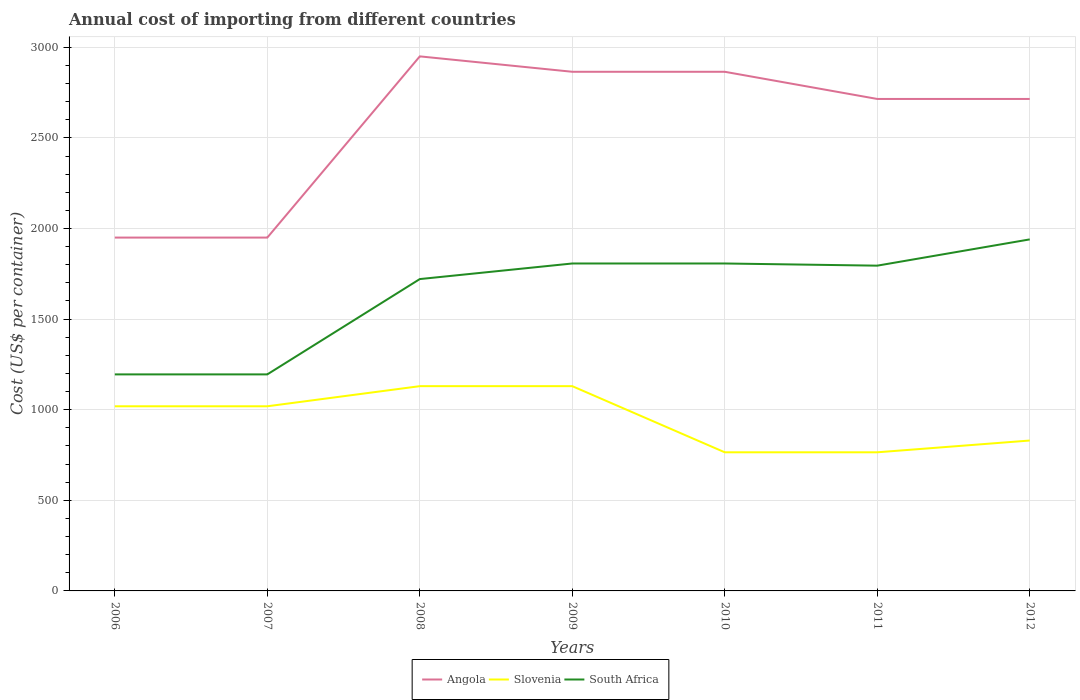How many different coloured lines are there?
Offer a very short reply. 3. Does the line corresponding to South Africa intersect with the line corresponding to Slovenia?
Your answer should be very brief. No. Is the number of lines equal to the number of legend labels?
Make the answer very short. Yes. Across all years, what is the maximum total annual cost of importing in Slovenia?
Give a very brief answer. 765. What is the total total annual cost of importing in Slovenia in the graph?
Your answer should be very brief. 189. What is the difference between the highest and the second highest total annual cost of importing in South Africa?
Offer a terse response. 745. What is the difference between the highest and the lowest total annual cost of importing in Slovenia?
Your answer should be very brief. 4. How many lines are there?
Keep it short and to the point. 3. Are the values on the major ticks of Y-axis written in scientific E-notation?
Give a very brief answer. No. Does the graph contain any zero values?
Your answer should be compact. No. How are the legend labels stacked?
Your response must be concise. Horizontal. What is the title of the graph?
Your response must be concise. Annual cost of importing from different countries. What is the label or title of the Y-axis?
Provide a succinct answer. Cost (US$ per container). What is the Cost (US$ per container) in Angola in 2006?
Keep it short and to the point. 1950. What is the Cost (US$ per container) in Slovenia in 2006?
Make the answer very short. 1019. What is the Cost (US$ per container) in South Africa in 2006?
Offer a terse response. 1195. What is the Cost (US$ per container) of Angola in 2007?
Your response must be concise. 1950. What is the Cost (US$ per container) in Slovenia in 2007?
Keep it short and to the point. 1019. What is the Cost (US$ per container) of South Africa in 2007?
Provide a succinct answer. 1195. What is the Cost (US$ per container) in Angola in 2008?
Keep it short and to the point. 2950. What is the Cost (US$ per container) of Slovenia in 2008?
Your response must be concise. 1130. What is the Cost (US$ per container) in South Africa in 2008?
Provide a short and direct response. 1721. What is the Cost (US$ per container) of Angola in 2009?
Provide a succinct answer. 2865. What is the Cost (US$ per container) of Slovenia in 2009?
Your answer should be very brief. 1130. What is the Cost (US$ per container) in South Africa in 2009?
Make the answer very short. 1807. What is the Cost (US$ per container) in Angola in 2010?
Provide a short and direct response. 2865. What is the Cost (US$ per container) of Slovenia in 2010?
Keep it short and to the point. 765. What is the Cost (US$ per container) in South Africa in 2010?
Your answer should be very brief. 1807. What is the Cost (US$ per container) in Angola in 2011?
Make the answer very short. 2715. What is the Cost (US$ per container) of Slovenia in 2011?
Provide a succinct answer. 765. What is the Cost (US$ per container) of South Africa in 2011?
Your response must be concise. 1795. What is the Cost (US$ per container) of Angola in 2012?
Provide a succinct answer. 2715. What is the Cost (US$ per container) in Slovenia in 2012?
Make the answer very short. 830. What is the Cost (US$ per container) of South Africa in 2012?
Provide a short and direct response. 1940. Across all years, what is the maximum Cost (US$ per container) of Angola?
Offer a very short reply. 2950. Across all years, what is the maximum Cost (US$ per container) of Slovenia?
Provide a succinct answer. 1130. Across all years, what is the maximum Cost (US$ per container) in South Africa?
Your response must be concise. 1940. Across all years, what is the minimum Cost (US$ per container) of Angola?
Keep it short and to the point. 1950. Across all years, what is the minimum Cost (US$ per container) of Slovenia?
Offer a terse response. 765. Across all years, what is the minimum Cost (US$ per container) of South Africa?
Offer a very short reply. 1195. What is the total Cost (US$ per container) of Angola in the graph?
Offer a terse response. 1.80e+04. What is the total Cost (US$ per container) in Slovenia in the graph?
Keep it short and to the point. 6658. What is the total Cost (US$ per container) of South Africa in the graph?
Offer a very short reply. 1.15e+04. What is the difference between the Cost (US$ per container) in Slovenia in 2006 and that in 2007?
Make the answer very short. 0. What is the difference between the Cost (US$ per container) of Angola in 2006 and that in 2008?
Keep it short and to the point. -1000. What is the difference between the Cost (US$ per container) of Slovenia in 2006 and that in 2008?
Your response must be concise. -111. What is the difference between the Cost (US$ per container) of South Africa in 2006 and that in 2008?
Your answer should be very brief. -526. What is the difference between the Cost (US$ per container) in Angola in 2006 and that in 2009?
Your answer should be compact. -915. What is the difference between the Cost (US$ per container) in Slovenia in 2006 and that in 2009?
Provide a succinct answer. -111. What is the difference between the Cost (US$ per container) in South Africa in 2006 and that in 2009?
Your answer should be compact. -612. What is the difference between the Cost (US$ per container) of Angola in 2006 and that in 2010?
Offer a terse response. -915. What is the difference between the Cost (US$ per container) in Slovenia in 2006 and that in 2010?
Give a very brief answer. 254. What is the difference between the Cost (US$ per container) of South Africa in 2006 and that in 2010?
Make the answer very short. -612. What is the difference between the Cost (US$ per container) of Angola in 2006 and that in 2011?
Give a very brief answer. -765. What is the difference between the Cost (US$ per container) in Slovenia in 2006 and that in 2011?
Ensure brevity in your answer.  254. What is the difference between the Cost (US$ per container) in South Africa in 2006 and that in 2011?
Your answer should be very brief. -600. What is the difference between the Cost (US$ per container) of Angola in 2006 and that in 2012?
Keep it short and to the point. -765. What is the difference between the Cost (US$ per container) in Slovenia in 2006 and that in 2012?
Provide a succinct answer. 189. What is the difference between the Cost (US$ per container) of South Africa in 2006 and that in 2012?
Ensure brevity in your answer.  -745. What is the difference between the Cost (US$ per container) in Angola in 2007 and that in 2008?
Provide a succinct answer. -1000. What is the difference between the Cost (US$ per container) in Slovenia in 2007 and that in 2008?
Provide a succinct answer. -111. What is the difference between the Cost (US$ per container) of South Africa in 2007 and that in 2008?
Give a very brief answer. -526. What is the difference between the Cost (US$ per container) in Angola in 2007 and that in 2009?
Give a very brief answer. -915. What is the difference between the Cost (US$ per container) in Slovenia in 2007 and that in 2009?
Your answer should be very brief. -111. What is the difference between the Cost (US$ per container) of South Africa in 2007 and that in 2009?
Make the answer very short. -612. What is the difference between the Cost (US$ per container) in Angola in 2007 and that in 2010?
Give a very brief answer. -915. What is the difference between the Cost (US$ per container) in Slovenia in 2007 and that in 2010?
Ensure brevity in your answer.  254. What is the difference between the Cost (US$ per container) of South Africa in 2007 and that in 2010?
Provide a succinct answer. -612. What is the difference between the Cost (US$ per container) in Angola in 2007 and that in 2011?
Provide a succinct answer. -765. What is the difference between the Cost (US$ per container) of Slovenia in 2007 and that in 2011?
Ensure brevity in your answer.  254. What is the difference between the Cost (US$ per container) in South Africa in 2007 and that in 2011?
Offer a terse response. -600. What is the difference between the Cost (US$ per container) of Angola in 2007 and that in 2012?
Provide a succinct answer. -765. What is the difference between the Cost (US$ per container) in Slovenia in 2007 and that in 2012?
Give a very brief answer. 189. What is the difference between the Cost (US$ per container) in South Africa in 2007 and that in 2012?
Your answer should be compact. -745. What is the difference between the Cost (US$ per container) of Angola in 2008 and that in 2009?
Give a very brief answer. 85. What is the difference between the Cost (US$ per container) in Slovenia in 2008 and that in 2009?
Give a very brief answer. 0. What is the difference between the Cost (US$ per container) of South Africa in 2008 and that in 2009?
Give a very brief answer. -86. What is the difference between the Cost (US$ per container) of Angola in 2008 and that in 2010?
Your answer should be compact. 85. What is the difference between the Cost (US$ per container) of Slovenia in 2008 and that in 2010?
Offer a terse response. 365. What is the difference between the Cost (US$ per container) in South Africa in 2008 and that in 2010?
Provide a short and direct response. -86. What is the difference between the Cost (US$ per container) in Angola in 2008 and that in 2011?
Your response must be concise. 235. What is the difference between the Cost (US$ per container) of Slovenia in 2008 and that in 2011?
Your response must be concise. 365. What is the difference between the Cost (US$ per container) in South Africa in 2008 and that in 2011?
Your answer should be very brief. -74. What is the difference between the Cost (US$ per container) of Angola in 2008 and that in 2012?
Ensure brevity in your answer.  235. What is the difference between the Cost (US$ per container) of Slovenia in 2008 and that in 2012?
Offer a terse response. 300. What is the difference between the Cost (US$ per container) in South Africa in 2008 and that in 2012?
Keep it short and to the point. -219. What is the difference between the Cost (US$ per container) of Slovenia in 2009 and that in 2010?
Your response must be concise. 365. What is the difference between the Cost (US$ per container) of South Africa in 2009 and that in 2010?
Your answer should be compact. 0. What is the difference between the Cost (US$ per container) of Angola in 2009 and that in 2011?
Your answer should be compact. 150. What is the difference between the Cost (US$ per container) in Slovenia in 2009 and that in 2011?
Give a very brief answer. 365. What is the difference between the Cost (US$ per container) of South Africa in 2009 and that in 2011?
Keep it short and to the point. 12. What is the difference between the Cost (US$ per container) in Angola in 2009 and that in 2012?
Offer a very short reply. 150. What is the difference between the Cost (US$ per container) in Slovenia in 2009 and that in 2012?
Your response must be concise. 300. What is the difference between the Cost (US$ per container) of South Africa in 2009 and that in 2012?
Ensure brevity in your answer.  -133. What is the difference between the Cost (US$ per container) in Angola in 2010 and that in 2011?
Your response must be concise. 150. What is the difference between the Cost (US$ per container) of Angola in 2010 and that in 2012?
Offer a very short reply. 150. What is the difference between the Cost (US$ per container) of Slovenia in 2010 and that in 2012?
Make the answer very short. -65. What is the difference between the Cost (US$ per container) of South Africa in 2010 and that in 2012?
Your response must be concise. -133. What is the difference between the Cost (US$ per container) of Angola in 2011 and that in 2012?
Keep it short and to the point. 0. What is the difference between the Cost (US$ per container) in Slovenia in 2011 and that in 2012?
Ensure brevity in your answer.  -65. What is the difference between the Cost (US$ per container) of South Africa in 2011 and that in 2012?
Make the answer very short. -145. What is the difference between the Cost (US$ per container) of Angola in 2006 and the Cost (US$ per container) of Slovenia in 2007?
Provide a short and direct response. 931. What is the difference between the Cost (US$ per container) in Angola in 2006 and the Cost (US$ per container) in South Africa in 2007?
Your answer should be very brief. 755. What is the difference between the Cost (US$ per container) of Slovenia in 2006 and the Cost (US$ per container) of South Africa in 2007?
Ensure brevity in your answer.  -176. What is the difference between the Cost (US$ per container) of Angola in 2006 and the Cost (US$ per container) of Slovenia in 2008?
Your response must be concise. 820. What is the difference between the Cost (US$ per container) of Angola in 2006 and the Cost (US$ per container) of South Africa in 2008?
Ensure brevity in your answer.  229. What is the difference between the Cost (US$ per container) of Slovenia in 2006 and the Cost (US$ per container) of South Africa in 2008?
Make the answer very short. -702. What is the difference between the Cost (US$ per container) of Angola in 2006 and the Cost (US$ per container) of Slovenia in 2009?
Keep it short and to the point. 820. What is the difference between the Cost (US$ per container) in Angola in 2006 and the Cost (US$ per container) in South Africa in 2009?
Your answer should be compact. 143. What is the difference between the Cost (US$ per container) in Slovenia in 2006 and the Cost (US$ per container) in South Africa in 2009?
Your answer should be very brief. -788. What is the difference between the Cost (US$ per container) in Angola in 2006 and the Cost (US$ per container) in Slovenia in 2010?
Provide a short and direct response. 1185. What is the difference between the Cost (US$ per container) of Angola in 2006 and the Cost (US$ per container) of South Africa in 2010?
Keep it short and to the point. 143. What is the difference between the Cost (US$ per container) in Slovenia in 2006 and the Cost (US$ per container) in South Africa in 2010?
Offer a very short reply. -788. What is the difference between the Cost (US$ per container) in Angola in 2006 and the Cost (US$ per container) in Slovenia in 2011?
Ensure brevity in your answer.  1185. What is the difference between the Cost (US$ per container) of Angola in 2006 and the Cost (US$ per container) of South Africa in 2011?
Provide a succinct answer. 155. What is the difference between the Cost (US$ per container) of Slovenia in 2006 and the Cost (US$ per container) of South Africa in 2011?
Keep it short and to the point. -776. What is the difference between the Cost (US$ per container) in Angola in 2006 and the Cost (US$ per container) in Slovenia in 2012?
Your answer should be very brief. 1120. What is the difference between the Cost (US$ per container) in Angola in 2006 and the Cost (US$ per container) in South Africa in 2012?
Your response must be concise. 10. What is the difference between the Cost (US$ per container) in Slovenia in 2006 and the Cost (US$ per container) in South Africa in 2012?
Your answer should be compact. -921. What is the difference between the Cost (US$ per container) of Angola in 2007 and the Cost (US$ per container) of Slovenia in 2008?
Your answer should be compact. 820. What is the difference between the Cost (US$ per container) in Angola in 2007 and the Cost (US$ per container) in South Africa in 2008?
Offer a very short reply. 229. What is the difference between the Cost (US$ per container) of Slovenia in 2007 and the Cost (US$ per container) of South Africa in 2008?
Your answer should be very brief. -702. What is the difference between the Cost (US$ per container) in Angola in 2007 and the Cost (US$ per container) in Slovenia in 2009?
Your answer should be very brief. 820. What is the difference between the Cost (US$ per container) of Angola in 2007 and the Cost (US$ per container) of South Africa in 2009?
Give a very brief answer. 143. What is the difference between the Cost (US$ per container) in Slovenia in 2007 and the Cost (US$ per container) in South Africa in 2009?
Offer a very short reply. -788. What is the difference between the Cost (US$ per container) of Angola in 2007 and the Cost (US$ per container) of Slovenia in 2010?
Offer a very short reply. 1185. What is the difference between the Cost (US$ per container) in Angola in 2007 and the Cost (US$ per container) in South Africa in 2010?
Your answer should be very brief. 143. What is the difference between the Cost (US$ per container) of Slovenia in 2007 and the Cost (US$ per container) of South Africa in 2010?
Ensure brevity in your answer.  -788. What is the difference between the Cost (US$ per container) of Angola in 2007 and the Cost (US$ per container) of Slovenia in 2011?
Your response must be concise. 1185. What is the difference between the Cost (US$ per container) in Angola in 2007 and the Cost (US$ per container) in South Africa in 2011?
Your answer should be very brief. 155. What is the difference between the Cost (US$ per container) in Slovenia in 2007 and the Cost (US$ per container) in South Africa in 2011?
Your answer should be very brief. -776. What is the difference between the Cost (US$ per container) of Angola in 2007 and the Cost (US$ per container) of Slovenia in 2012?
Your answer should be compact. 1120. What is the difference between the Cost (US$ per container) of Slovenia in 2007 and the Cost (US$ per container) of South Africa in 2012?
Provide a short and direct response. -921. What is the difference between the Cost (US$ per container) of Angola in 2008 and the Cost (US$ per container) of Slovenia in 2009?
Your answer should be compact. 1820. What is the difference between the Cost (US$ per container) of Angola in 2008 and the Cost (US$ per container) of South Africa in 2009?
Provide a succinct answer. 1143. What is the difference between the Cost (US$ per container) of Slovenia in 2008 and the Cost (US$ per container) of South Africa in 2009?
Keep it short and to the point. -677. What is the difference between the Cost (US$ per container) of Angola in 2008 and the Cost (US$ per container) of Slovenia in 2010?
Offer a very short reply. 2185. What is the difference between the Cost (US$ per container) in Angola in 2008 and the Cost (US$ per container) in South Africa in 2010?
Your answer should be very brief. 1143. What is the difference between the Cost (US$ per container) of Slovenia in 2008 and the Cost (US$ per container) of South Africa in 2010?
Make the answer very short. -677. What is the difference between the Cost (US$ per container) in Angola in 2008 and the Cost (US$ per container) in Slovenia in 2011?
Give a very brief answer. 2185. What is the difference between the Cost (US$ per container) in Angola in 2008 and the Cost (US$ per container) in South Africa in 2011?
Provide a short and direct response. 1155. What is the difference between the Cost (US$ per container) of Slovenia in 2008 and the Cost (US$ per container) of South Africa in 2011?
Your answer should be compact. -665. What is the difference between the Cost (US$ per container) in Angola in 2008 and the Cost (US$ per container) in Slovenia in 2012?
Your answer should be very brief. 2120. What is the difference between the Cost (US$ per container) of Angola in 2008 and the Cost (US$ per container) of South Africa in 2012?
Give a very brief answer. 1010. What is the difference between the Cost (US$ per container) in Slovenia in 2008 and the Cost (US$ per container) in South Africa in 2012?
Make the answer very short. -810. What is the difference between the Cost (US$ per container) of Angola in 2009 and the Cost (US$ per container) of Slovenia in 2010?
Keep it short and to the point. 2100. What is the difference between the Cost (US$ per container) in Angola in 2009 and the Cost (US$ per container) in South Africa in 2010?
Provide a succinct answer. 1058. What is the difference between the Cost (US$ per container) of Slovenia in 2009 and the Cost (US$ per container) of South Africa in 2010?
Your response must be concise. -677. What is the difference between the Cost (US$ per container) of Angola in 2009 and the Cost (US$ per container) of Slovenia in 2011?
Your response must be concise. 2100. What is the difference between the Cost (US$ per container) in Angola in 2009 and the Cost (US$ per container) in South Africa in 2011?
Your answer should be very brief. 1070. What is the difference between the Cost (US$ per container) of Slovenia in 2009 and the Cost (US$ per container) of South Africa in 2011?
Keep it short and to the point. -665. What is the difference between the Cost (US$ per container) of Angola in 2009 and the Cost (US$ per container) of Slovenia in 2012?
Provide a short and direct response. 2035. What is the difference between the Cost (US$ per container) of Angola in 2009 and the Cost (US$ per container) of South Africa in 2012?
Provide a succinct answer. 925. What is the difference between the Cost (US$ per container) of Slovenia in 2009 and the Cost (US$ per container) of South Africa in 2012?
Provide a succinct answer. -810. What is the difference between the Cost (US$ per container) in Angola in 2010 and the Cost (US$ per container) in Slovenia in 2011?
Give a very brief answer. 2100. What is the difference between the Cost (US$ per container) of Angola in 2010 and the Cost (US$ per container) of South Africa in 2011?
Your response must be concise. 1070. What is the difference between the Cost (US$ per container) in Slovenia in 2010 and the Cost (US$ per container) in South Africa in 2011?
Keep it short and to the point. -1030. What is the difference between the Cost (US$ per container) of Angola in 2010 and the Cost (US$ per container) of Slovenia in 2012?
Offer a terse response. 2035. What is the difference between the Cost (US$ per container) in Angola in 2010 and the Cost (US$ per container) in South Africa in 2012?
Your answer should be compact. 925. What is the difference between the Cost (US$ per container) of Slovenia in 2010 and the Cost (US$ per container) of South Africa in 2012?
Your answer should be very brief. -1175. What is the difference between the Cost (US$ per container) of Angola in 2011 and the Cost (US$ per container) of Slovenia in 2012?
Your answer should be compact. 1885. What is the difference between the Cost (US$ per container) of Angola in 2011 and the Cost (US$ per container) of South Africa in 2012?
Provide a succinct answer. 775. What is the difference between the Cost (US$ per container) of Slovenia in 2011 and the Cost (US$ per container) of South Africa in 2012?
Offer a terse response. -1175. What is the average Cost (US$ per container) of Angola per year?
Your answer should be compact. 2572.86. What is the average Cost (US$ per container) in Slovenia per year?
Provide a succinct answer. 951.14. What is the average Cost (US$ per container) of South Africa per year?
Your answer should be compact. 1637.14. In the year 2006, what is the difference between the Cost (US$ per container) in Angola and Cost (US$ per container) in Slovenia?
Make the answer very short. 931. In the year 2006, what is the difference between the Cost (US$ per container) in Angola and Cost (US$ per container) in South Africa?
Your answer should be compact. 755. In the year 2006, what is the difference between the Cost (US$ per container) of Slovenia and Cost (US$ per container) of South Africa?
Provide a succinct answer. -176. In the year 2007, what is the difference between the Cost (US$ per container) of Angola and Cost (US$ per container) of Slovenia?
Provide a succinct answer. 931. In the year 2007, what is the difference between the Cost (US$ per container) of Angola and Cost (US$ per container) of South Africa?
Your answer should be compact. 755. In the year 2007, what is the difference between the Cost (US$ per container) of Slovenia and Cost (US$ per container) of South Africa?
Make the answer very short. -176. In the year 2008, what is the difference between the Cost (US$ per container) of Angola and Cost (US$ per container) of Slovenia?
Ensure brevity in your answer.  1820. In the year 2008, what is the difference between the Cost (US$ per container) in Angola and Cost (US$ per container) in South Africa?
Ensure brevity in your answer.  1229. In the year 2008, what is the difference between the Cost (US$ per container) in Slovenia and Cost (US$ per container) in South Africa?
Give a very brief answer. -591. In the year 2009, what is the difference between the Cost (US$ per container) of Angola and Cost (US$ per container) of Slovenia?
Give a very brief answer. 1735. In the year 2009, what is the difference between the Cost (US$ per container) in Angola and Cost (US$ per container) in South Africa?
Offer a very short reply. 1058. In the year 2009, what is the difference between the Cost (US$ per container) of Slovenia and Cost (US$ per container) of South Africa?
Your answer should be compact. -677. In the year 2010, what is the difference between the Cost (US$ per container) in Angola and Cost (US$ per container) in Slovenia?
Provide a succinct answer. 2100. In the year 2010, what is the difference between the Cost (US$ per container) of Angola and Cost (US$ per container) of South Africa?
Ensure brevity in your answer.  1058. In the year 2010, what is the difference between the Cost (US$ per container) in Slovenia and Cost (US$ per container) in South Africa?
Your answer should be compact. -1042. In the year 2011, what is the difference between the Cost (US$ per container) of Angola and Cost (US$ per container) of Slovenia?
Make the answer very short. 1950. In the year 2011, what is the difference between the Cost (US$ per container) of Angola and Cost (US$ per container) of South Africa?
Ensure brevity in your answer.  920. In the year 2011, what is the difference between the Cost (US$ per container) of Slovenia and Cost (US$ per container) of South Africa?
Ensure brevity in your answer.  -1030. In the year 2012, what is the difference between the Cost (US$ per container) of Angola and Cost (US$ per container) of Slovenia?
Make the answer very short. 1885. In the year 2012, what is the difference between the Cost (US$ per container) of Angola and Cost (US$ per container) of South Africa?
Offer a very short reply. 775. In the year 2012, what is the difference between the Cost (US$ per container) of Slovenia and Cost (US$ per container) of South Africa?
Your answer should be compact. -1110. What is the ratio of the Cost (US$ per container) of Angola in 2006 to that in 2007?
Offer a terse response. 1. What is the ratio of the Cost (US$ per container) in South Africa in 2006 to that in 2007?
Your response must be concise. 1. What is the ratio of the Cost (US$ per container) of Angola in 2006 to that in 2008?
Offer a terse response. 0.66. What is the ratio of the Cost (US$ per container) in Slovenia in 2006 to that in 2008?
Offer a very short reply. 0.9. What is the ratio of the Cost (US$ per container) in South Africa in 2006 to that in 2008?
Provide a succinct answer. 0.69. What is the ratio of the Cost (US$ per container) of Angola in 2006 to that in 2009?
Offer a terse response. 0.68. What is the ratio of the Cost (US$ per container) in Slovenia in 2006 to that in 2009?
Offer a terse response. 0.9. What is the ratio of the Cost (US$ per container) in South Africa in 2006 to that in 2009?
Provide a short and direct response. 0.66. What is the ratio of the Cost (US$ per container) of Angola in 2006 to that in 2010?
Your answer should be compact. 0.68. What is the ratio of the Cost (US$ per container) in Slovenia in 2006 to that in 2010?
Give a very brief answer. 1.33. What is the ratio of the Cost (US$ per container) in South Africa in 2006 to that in 2010?
Keep it short and to the point. 0.66. What is the ratio of the Cost (US$ per container) of Angola in 2006 to that in 2011?
Your response must be concise. 0.72. What is the ratio of the Cost (US$ per container) in Slovenia in 2006 to that in 2011?
Ensure brevity in your answer.  1.33. What is the ratio of the Cost (US$ per container) of South Africa in 2006 to that in 2011?
Your answer should be very brief. 0.67. What is the ratio of the Cost (US$ per container) of Angola in 2006 to that in 2012?
Your answer should be compact. 0.72. What is the ratio of the Cost (US$ per container) of Slovenia in 2006 to that in 2012?
Ensure brevity in your answer.  1.23. What is the ratio of the Cost (US$ per container) in South Africa in 2006 to that in 2012?
Offer a terse response. 0.62. What is the ratio of the Cost (US$ per container) in Angola in 2007 to that in 2008?
Your response must be concise. 0.66. What is the ratio of the Cost (US$ per container) of Slovenia in 2007 to that in 2008?
Keep it short and to the point. 0.9. What is the ratio of the Cost (US$ per container) in South Africa in 2007 to that in 2008?
Keep it short and to the point. 0.69. What is the ratio of the Cost (US$ per container) in Angola in 2007 to that in 2009?
Offer a very short reply. 0.68. What is the ratio of the Cost (US$ per container) in Slovenia in 2007 to that in 2009?
Make the answer very short. 0.9. What is the ratio of the Cost (US$ per container) in South Africa in 2007 to that in 2009?
Provide a short and direct response. 0.66. What is the ratio of the Cost (US$ per container) in Angola in 2007 to that in 2010?
Ensure brevity in your answer.  0.68. What is the ratio of the Cost (US$ per container) of Slovenia in 2007 to that in 2010?
Make the answer very short. 1.33. What is the ratio of the Cost (US$ per container) in South Africa in 2007 to that in 2010?
Your answer should be very brief. 0.66. What is the ratio of the Cost (US$ per container) of Angola in 2007 to that in 2011?
Make the answer very short. 0.72. What is the ratio of the Cost (US$ per container) of Slovenia in 2007 to that in 2011?
Ensure brevity in your answer.  1.33. What is the ratio of the Cost (US$ per container) in South Africa in 2007 to that in 2011?
Provide a short and direct response. 0.67. What is the ratio of the Cost (US$ per container) in Angola in 2007 to that in 2012?
Your answer should be very brief. 0.72. What is the ratio of the Cost (US$ per container) of Slovenia in 2007 to that in 2012?
Make the answer very short. 1.23. What is the ratio of the Cost (US$ per container) in South Africa in 2007 to that in 2012?
Offer a terse response. 0.62. What is the ratio of the Cost (US$ per container) of Angola in 2008 to that in 2009?
Offer a terse response. 1.03. What is the ratio of the Cost (US$ per container) of Angola in 2008 to that in 2010?
Give a very brief answer. 1.03. What is the ratio of the Cost (US$ per container) in Slovenia in 2008 to that in 2010?
Make the answer very short. 1.48. What is the ratio of the Cost (US$ per container) in South Africa in 2008 to that in 2010?
Make the answer very short. 0.95. What is the ratio of the Cost (US$ per container) of Angola in 2008 to that in 2011?
Your answer should be very brief. 1.09. What is the ratio of the Cost (US$ per container) of Slovenia in 2008 to that in 2011?
Your answer should be very brief. 1.48. What is the ratio of the Cost (US$ per container) in South Africa in 2008 to that in 2011?
Your answer should be compact. 0.96. What is the ratio of the Cost (US$ per container) in Angola in 2008 to that in 2012?
Provide a succinct answer. 1.09. What is the ratio of the Cost (US$ per container) in Slovenia in 2008 to that in 2012?
Provide a succinct answer. 1.36. What is the ratio of the Cost (US$ per container) in South Africa in 2008 to that in 2012?
Make the answer very short. 0.89. What is the ratio of the Cost (US$ per container) of Angola in 2009 to that in 2010?
Offer a very short reply. 1. What is the ratio of the Cost (US$ per container) in Slovenia in 2009 to that in 2010?
Ensure brevity in your answer.  1.48. What is the ratio of the Cost (US$ per container) in South Africa in 2009 to that in 2010?
Provide a short and direct response. 1. What is the ratio of the Cost (US$ per container) of Angola in 2009 to that in 2011?
Your response must be concise. 1.06. What is the ratio of the Cost (US$ per container) of Slovenia in 2009 to that in 2011?
Give a very brief answer. 1.48. What is the ratio of the Cost (US$ per container) in Angola in 2009 to that in 2012?
Offer a terse response. 1.06. What is the ratio of the Cost (US$ per container) in Slovenia in 2009 to that in 2012?
Keep it short and to the point. 1.36. What is the ratio of the Cost (US$ per container) in South Africa in 2009 to that in 2012?
Your answer should be compact. 0.93. What is the ratio of the Cost (US$ per container) of Angola in 2010 to that in 2011?
Your answer should be compact. 1.06. What is the ratio of the Cost (US$ per container) in Angola in 2010 to that in 2012?
Your answer should be compact. 1.06. What is the ratio of the Cost (US$ per container) of Slovenia in 2010 to that in 2012?
Ensure brevity in your answer.  0.92. What is the ratio of the Cost (US$ per container) of South Africa in 2010 to that in 2012?
Offer a terse response. 0.93. What is the ratio of the Cost (US$ per container) of Slovenia in 2011 to that in 2012?
Ensure brevity in your answer.  0.92. What is the ratio of the Cost (US$ per container) in South Africa in 2011 to that in 2012?
Provide a short and direct response. 0.93. What is the difference between the highest and the second highest Cost (US$ per container) in South Africa?
Your response must be concise. 133. What is the difference between the highest and the lowest Cost (US$ per container) in Slovenia?
Keep it short and to the point. 365. What is the difference between the highest and the lowest Cost (US$ per container) in South Africa?
Ensure brevity in your answer.  745. 